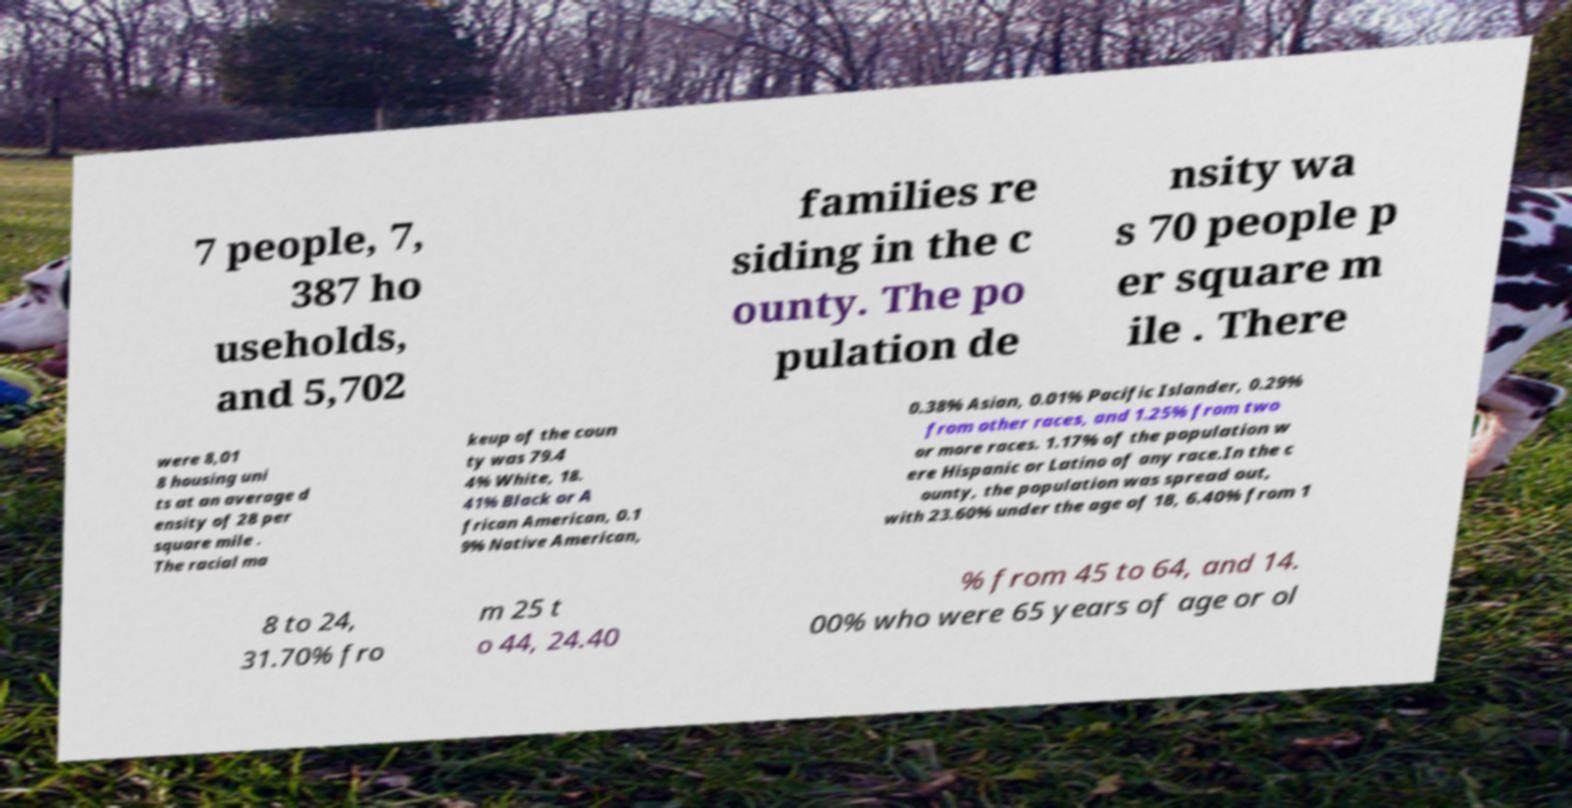What messages or text are displayed in this image? I need them in a readable, typed format. 7 people, 7, 387 ho useholds, and 5,702 families re siding in the c ounty. The po pulation de nsity wa s 70 people p er square m ile . There were 8,01 8 housing uni ts at an average d ensity of 28 per square mile . The racial ma keup of the coun ty was 79.4 4% White, 18. 41% Black or A frican American, 0.1 9% Native American, 0.38% Asian, 0.01% Pacific Islander, 0.29% from other races, and 1.25% from two or more races. 1.17% of the population w ere Hispanic or Latino of any race.In the c ounty, the population was spread out, with 23.60% under the age of 18, 6.40% from 1 8 to 24, 31.70% fro m 25 t o 44, 24.40 % from 45 to 64, and 14. 00% who were 65 years of age or ol 